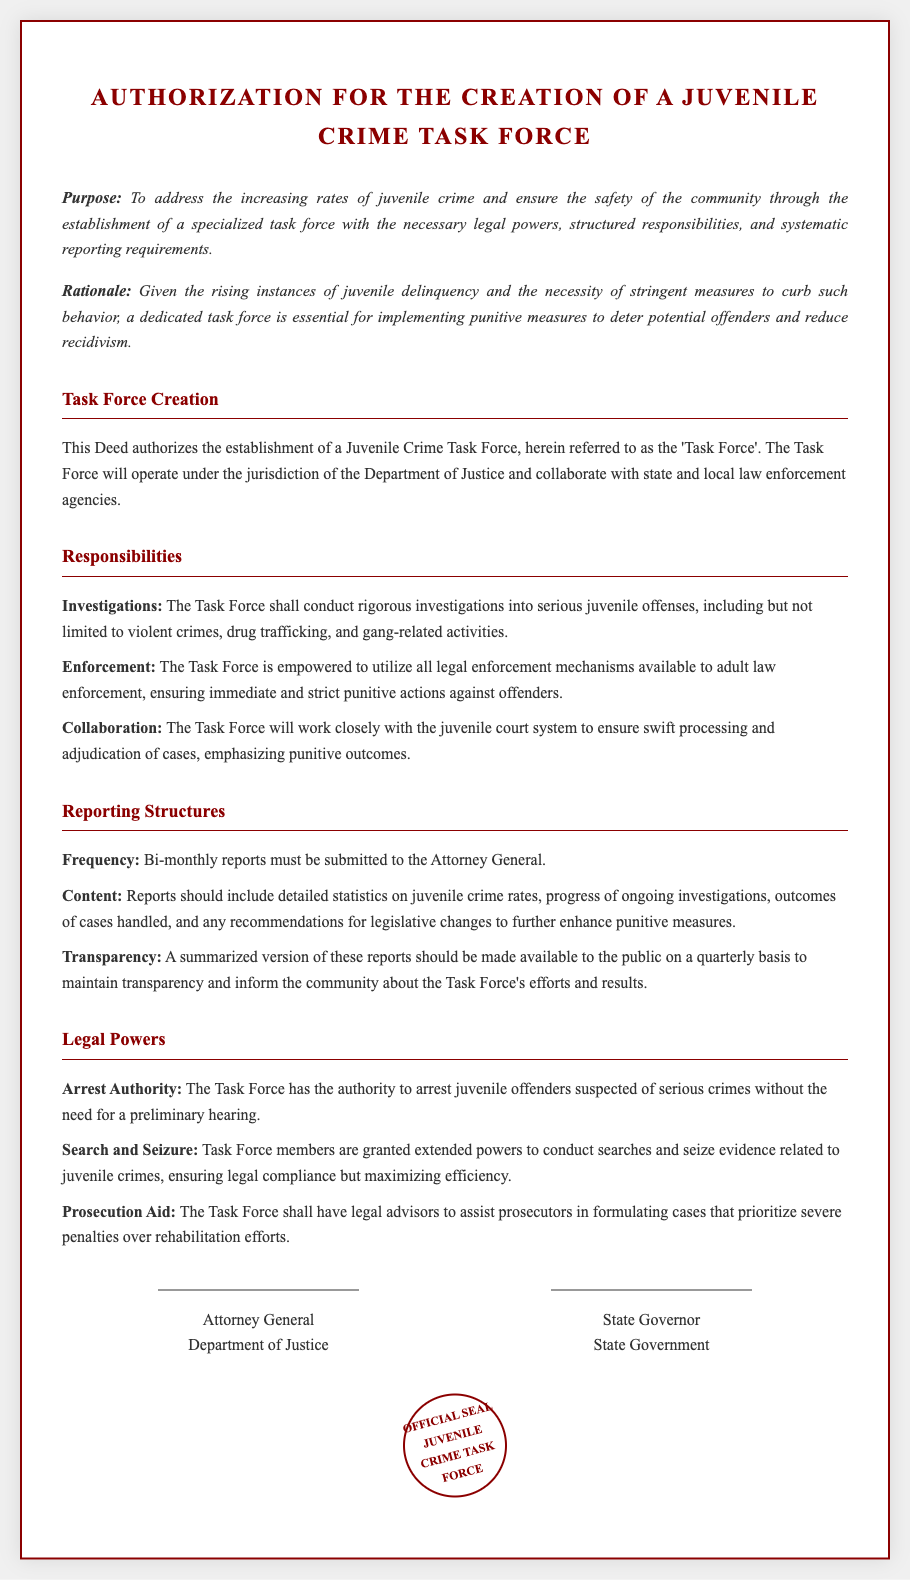What is the title of the document? The title of the document is clearly stated at the top of the rendered document as the main heading.
Answer: Authorization for the Creation of a Juvenile Crime Task Force Who is the authorizing body for the Task Force? The document specifies that the Task Force will operate under the jurisdiction of a specific department for legal authority.
Answer: Department of Justice What is the reporting frequency required for the Task Force? The document outlines how often reports must be submitted, indicating the regularity of reporting for oversight.
Answer: Bi-monthly What types of crimes will the Task Force investigate? The responsibilities section provides examples of serious offenses that the Task Force will focus on, detailing specific crime categories.
Answer: Violent crimes, drug trafficking, gang-related activities How many signatures are required on this Deed? The document indicates two specific positions that need to sign, representing the responsible parties for this initiative.
Answer: Two What is the purpose of establishing this Task Force? The document clearly states the intended goal of creating the Task Force, providing a rationale for its existence.
Answer: To address the increasing rates of juvenile crime What power is granted for arresting offenders? The legal powers section specifies a key authority granted to the Task Force, particularly related to detaining suspects.
Answer: Arrest authority without a preliminary hearing What is one responsibility of the Task Force related to the juvenile court? The document enumerates specific tasks and functions the Task Force will carry out in relation to the judicial system.
Answer: Ensure swift processing and adjudication of cases What document feature emphasizes the official nature of the Deed? The presence of this feature at the bottom of the document indicates its formal validation and authenticity.
Answer: Official Seal 